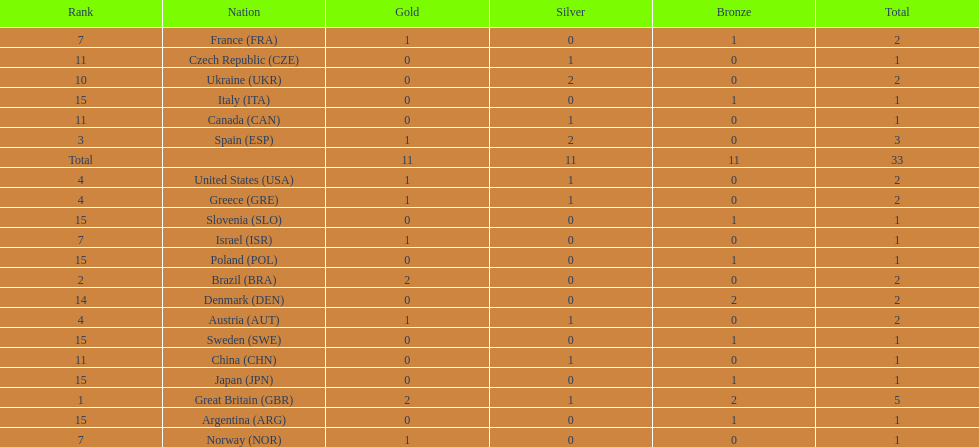Who won more gold medals than spain? Great Britain (GBR), Brazil (BRA). 